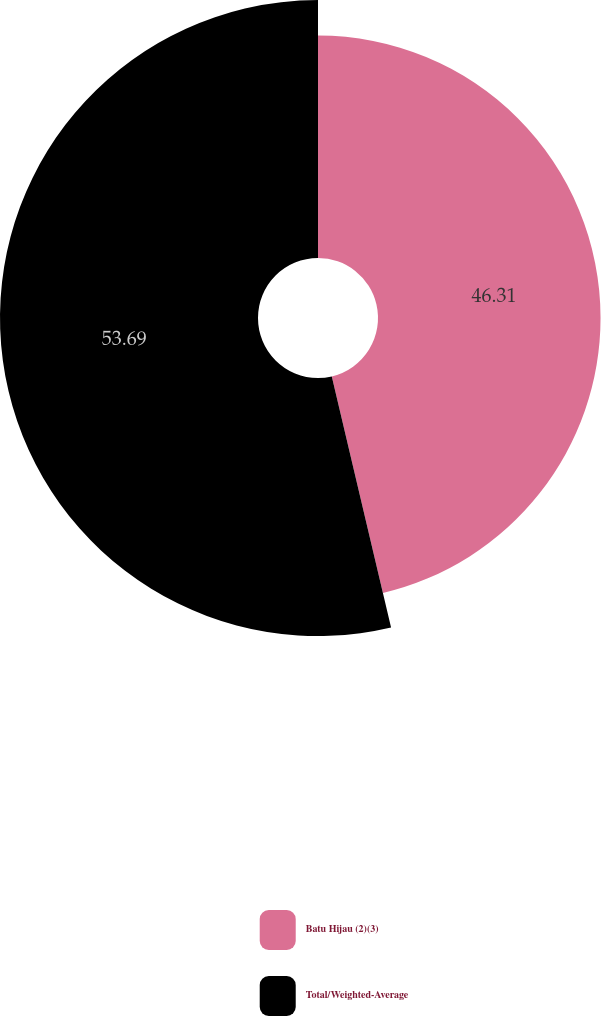Convert chart. <chart><loc_0><loc_0><loc_500><loc_500><pie_chart><fcel>Batu Hijau (2)(3)<fcel>Total/Weighted-Average<nl><fcel>46.31%<fcel>53.69%<nl></chart> 